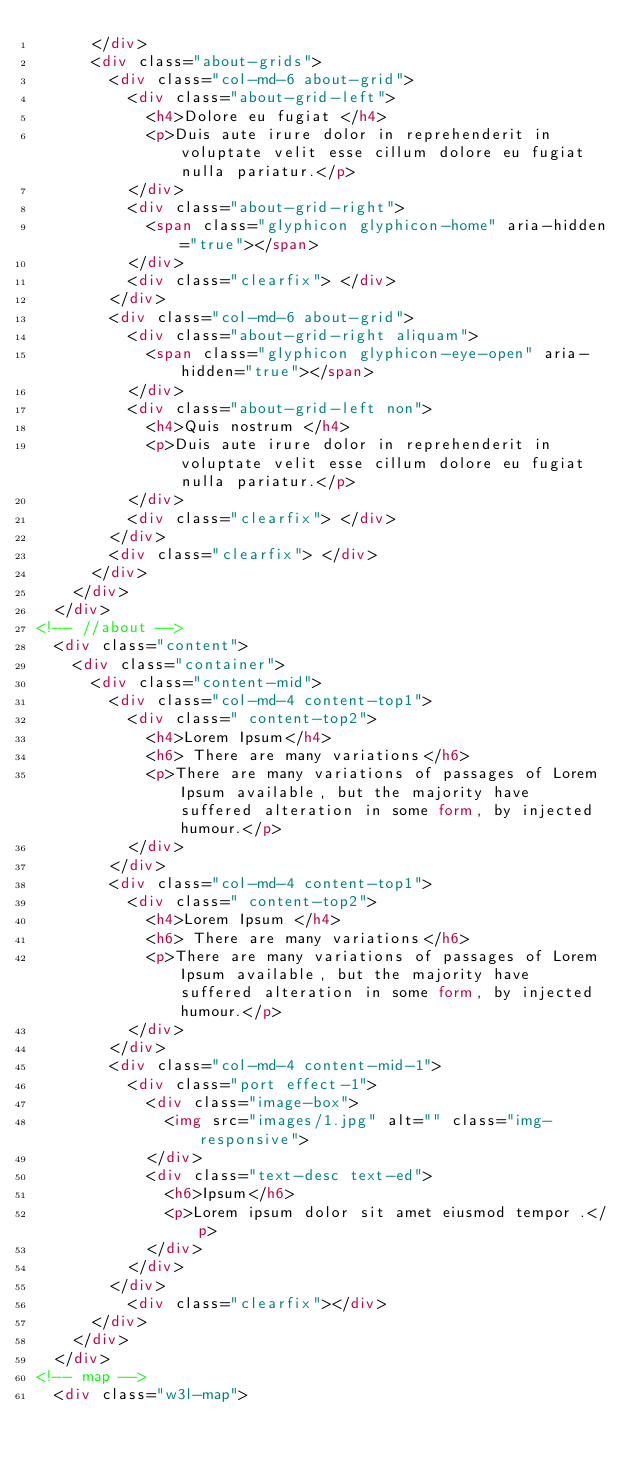Convert code to text. <code><loc_0><loc_0><loc_500><loc_500><_HTML_>			</div>
			<div class="about-grids">
				<div class="col-md-6 about-grid">
					<div class="about-grid-left">
						<h4>Dolore eu fugiat </h4>
						<p>Duis aute irure dolor in reprehenderit in voluptate velit esse cillum dolore eu fugiat nulla pariatur.</p>
					</div>
					<div class="about-grid-right">
						<span class="glyphicon glyphicon-home" aria-hidden="true"></span>
					</div>
					<div class="clearfix"> </div>
				</div>
				<div class="col-md-6 about-grid">
					<div class="about-grid-right aliquam">
						<span class="glyphicon glyphicon-eye-open" aria-hidden="true"></span>
					</div>
					<div class="about-grid-left non">
						<h4>Quis nostrum </h4>
						<p>Duis aute irure dolor in reprehenderit in voluptate velit esse cillum dolore eu fugiat nulla pariatur.</p>
					</div>					
					<div class="clearfix"> </div>
				</div>
				<div class="clearfix"> </div>
			</div>
		</div>
	</div>
<!-- //about -->
	<div class="content">
		<div class="container">
			<div class="content-mid">
				<div class="col-md-4 content-top1">
					<div class=" content-top2">
						<h4>Lorem Ipsum</h4>
						<h6> There are many variations</h6>
						<p>There are many variations of passages of Lorem Ipsum available, but the majority have suffered alteration in some form, by injected humour.</p>
					</div>
				</div>
				<div class="col-md-4 content-top1">
					<div class=" content-top2">
						<h4>Lorem Ipsum </h4>
						<h6> There are many variations</h6>
						<p>There are many variations of passages of Lorem Ipsum available, but the majority have suffered alteration in some form, by injected humour.</p>
					</div>
				</div>
				<div class="col-md-4 content-mid-1">
					<div class="port effect-1">
						<div class="image-box">
							<img src="images/1.jpg" alt="" class="img-responsive">
						</div>
						<div class="text-desc text-ed">
							<h6>Ipsum</h6>
							<p>Lorem ipsum dolor sit amet eiusmod tempor .</p>	
						</div>
					</div>
				</div>
					<div class="clearfix"></div>
			</div>
		</div>
	</div>
<!-- map -->
	<div class="w3l-map"></code> 